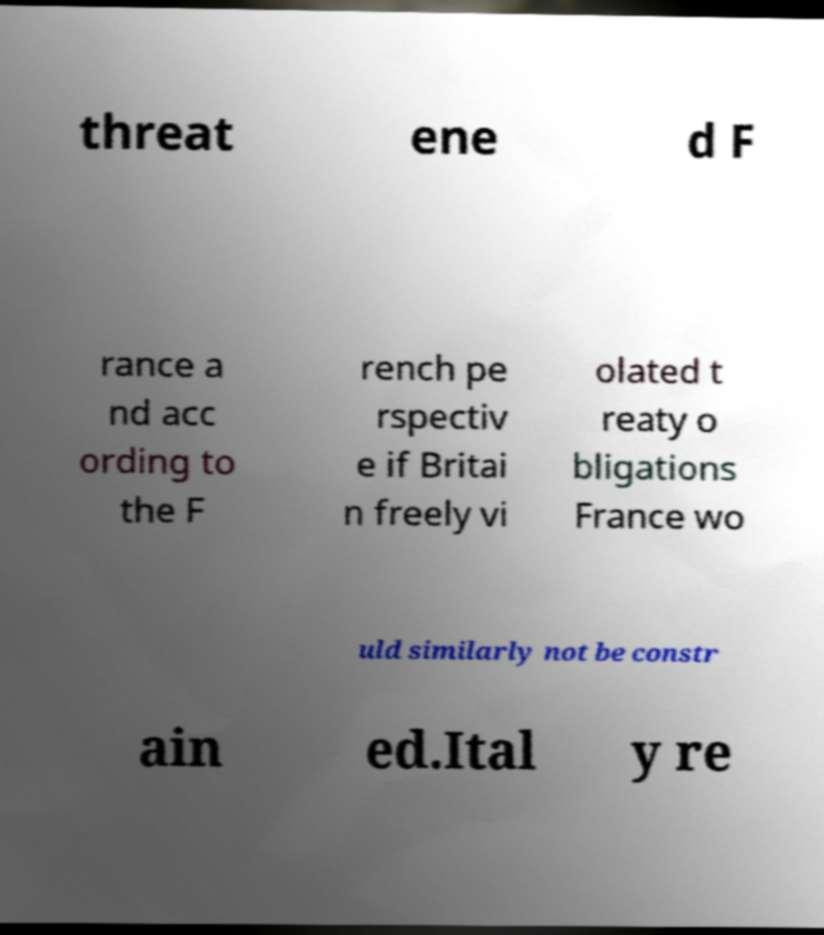I need the written content from this picture converted into text. Can you do that? threat ene d F rance a nd acc ording to the F rench pe rspectiv e if Britai n freely vi olated t reaty o bligations France wo uld similarly not be constr ain ed.Ital y re 